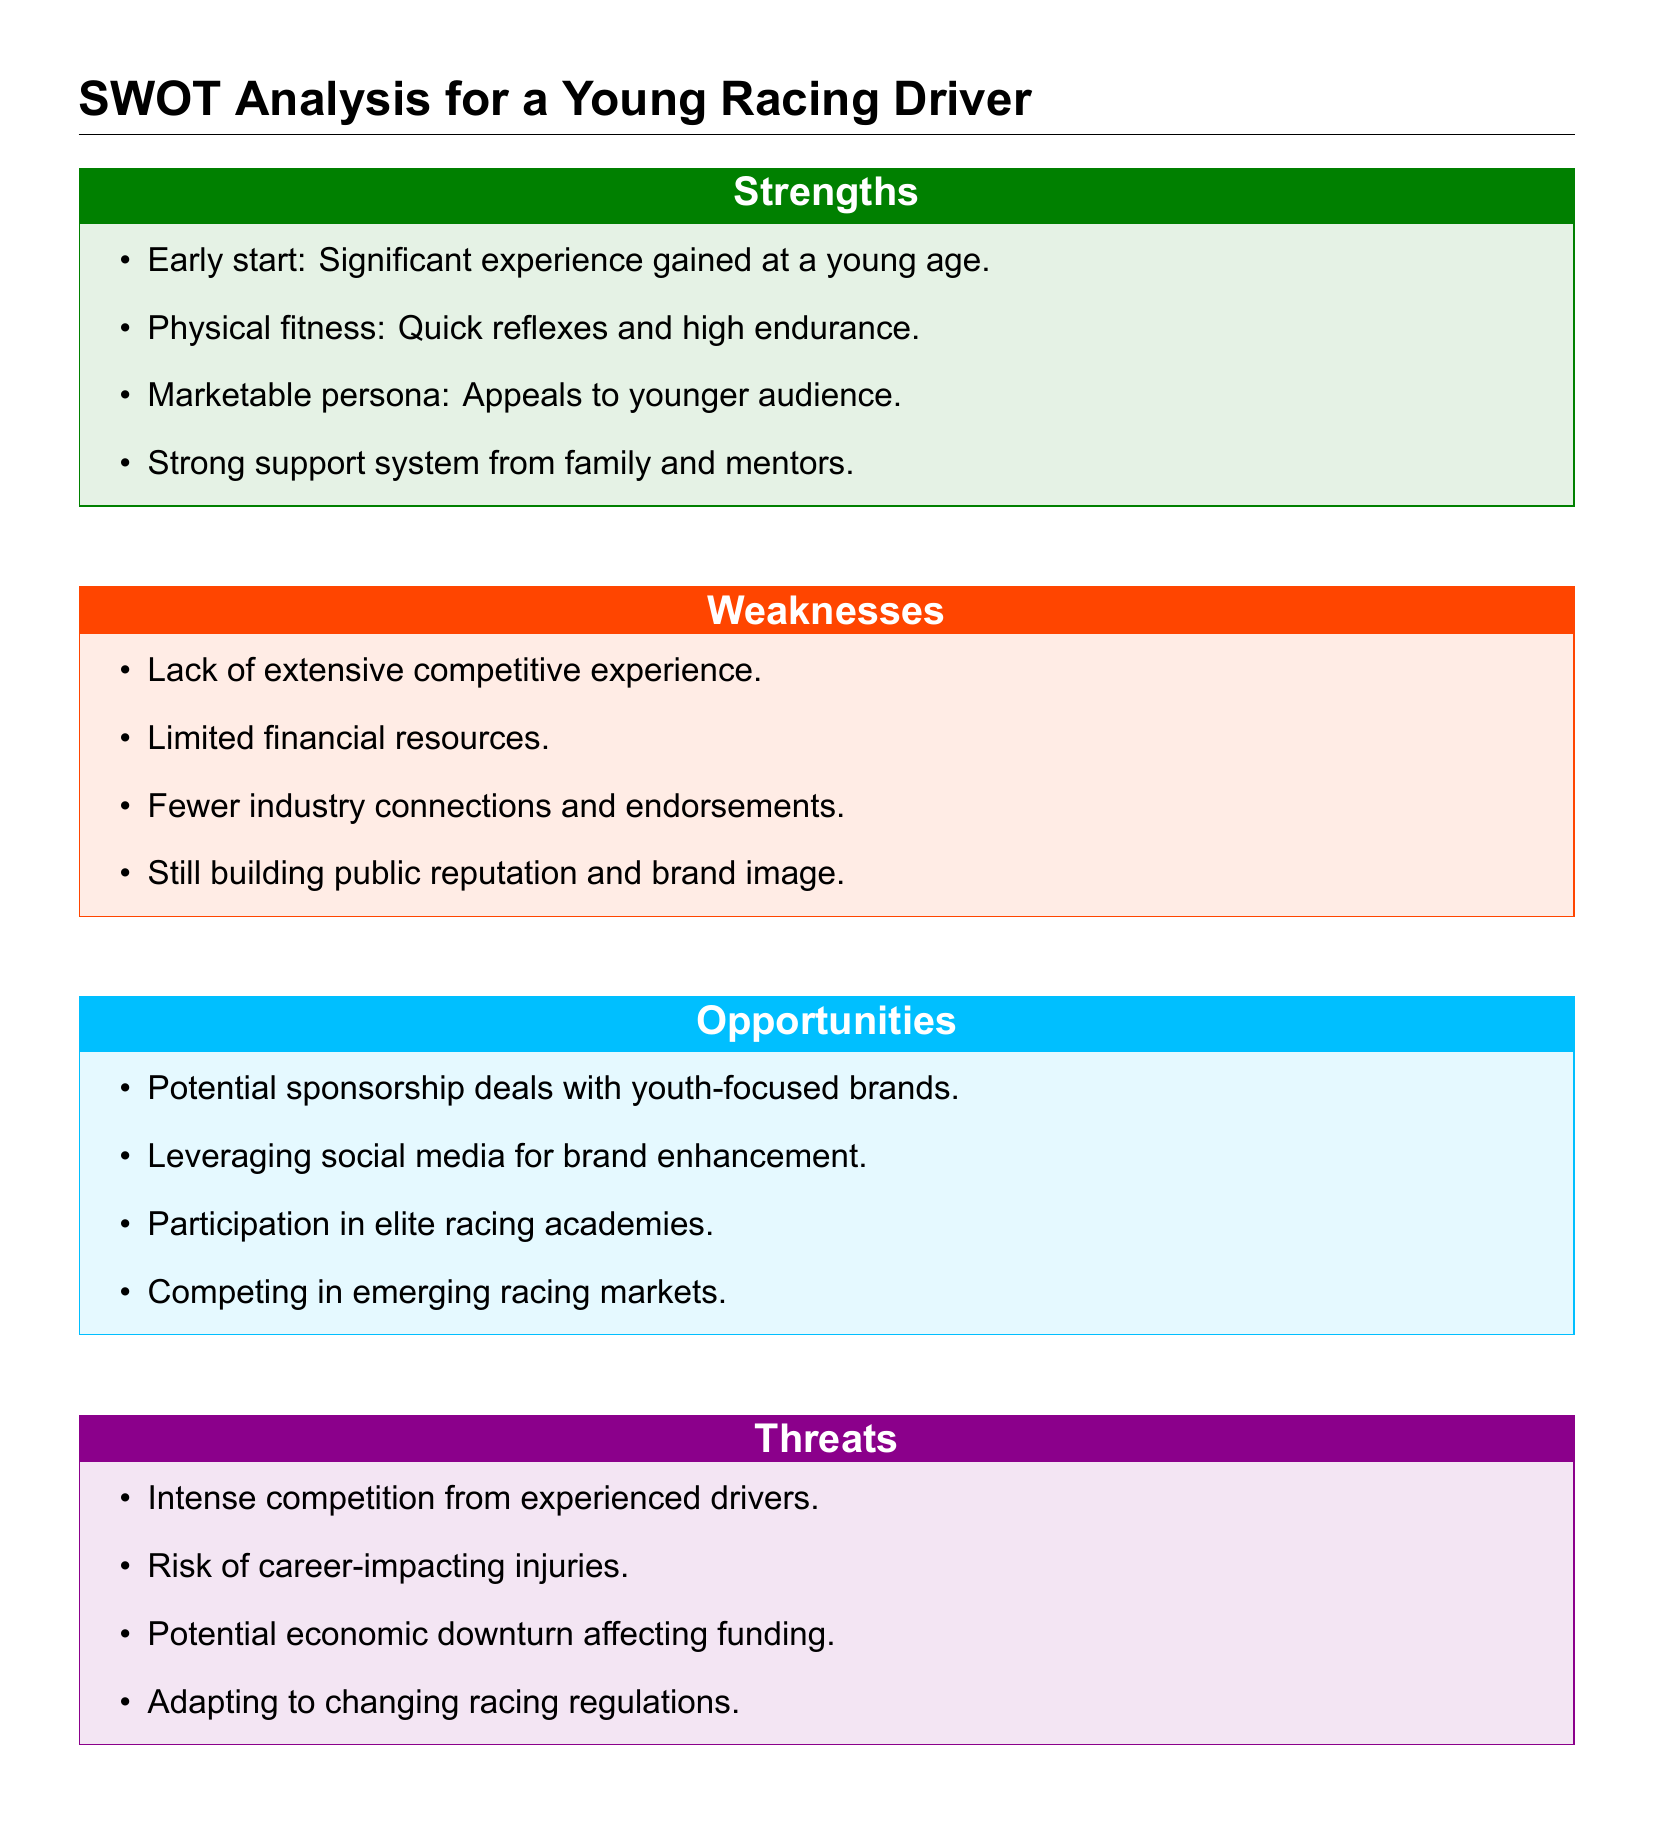What is a strength of the young racing driver? The document mentions several strengths, including experience gained at a young age.
Answer: Significant experience gained at a young age What is a weakness identified for the driver? The document lists weaknesses, one of which is limited financial resources.
Answer: Limited financial resources What opportunity can the driver pursue? One opportunity mentioned is participation in elite racing academies.
Answer: Participation in elite racing academies What threat is associated with intense competition? The document notes that intense competition comes from experienced drivers.
Answer: Experienced drivers How many weaknesses are listed in the document? The document contains a total of four weaknesses.
Answer: Four Which factor enhances the driver's marketability? The document indicates that appealing to a younger audience enhances marketability.
Answer: Appeals to younger audience What kind of deals could the driver potentially pursue? The document suggests potential sponsorship deals.
Answer: Sponsorship deals What is a potential risk noted in the threats section? One potential risk mentioned is the risk of career-impacting injuries.
Answer: Risk of career-impacting injuries What color represents the opportunities in the document? The document uses a specific color for opportunities which is a light blue color.
Answer: Light blue 